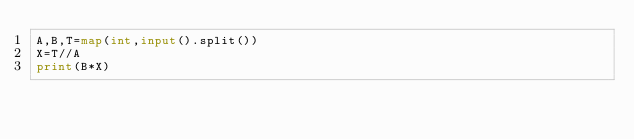Convert code to text. <code><loc_0><loc_0><loc_500><loc_500><_Python_>A,B,T=map(int,input().split())
X=T//A
print(B*X)
</code> 